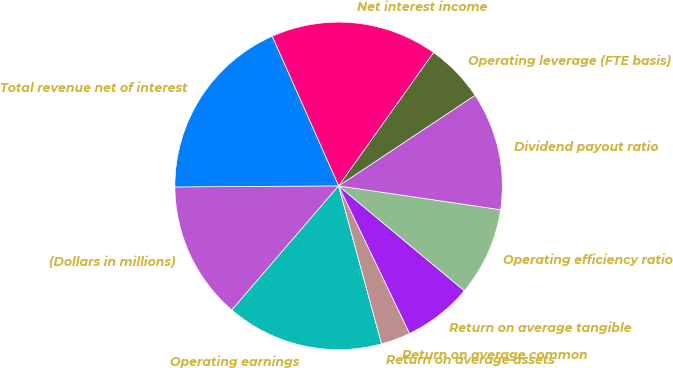<chart> <loc_0><loc_0><loc_500><loc_500><pie_chart><fcel>(Dollars in millions)<fcel>Operating earnings<fcel>Return on average assets<fcel>Return on average common<fcel>Return on average tangible<fcel>Operating efficiency ratio<fcel>Dividend payout ratio<fcel>Operating leverage (FTE basis)<fcel>Net interest income<fcel>Total revenue net of interest<nl><fcel>13.59%<fcel>15.53%<fcel>0.0%<fcel>2.91%<fcel>6.8%<fcel>8.74%<fcel>11.65%<fcel>5.83%<fcel>16.5%<fcel>18.45%<nl></chart> 